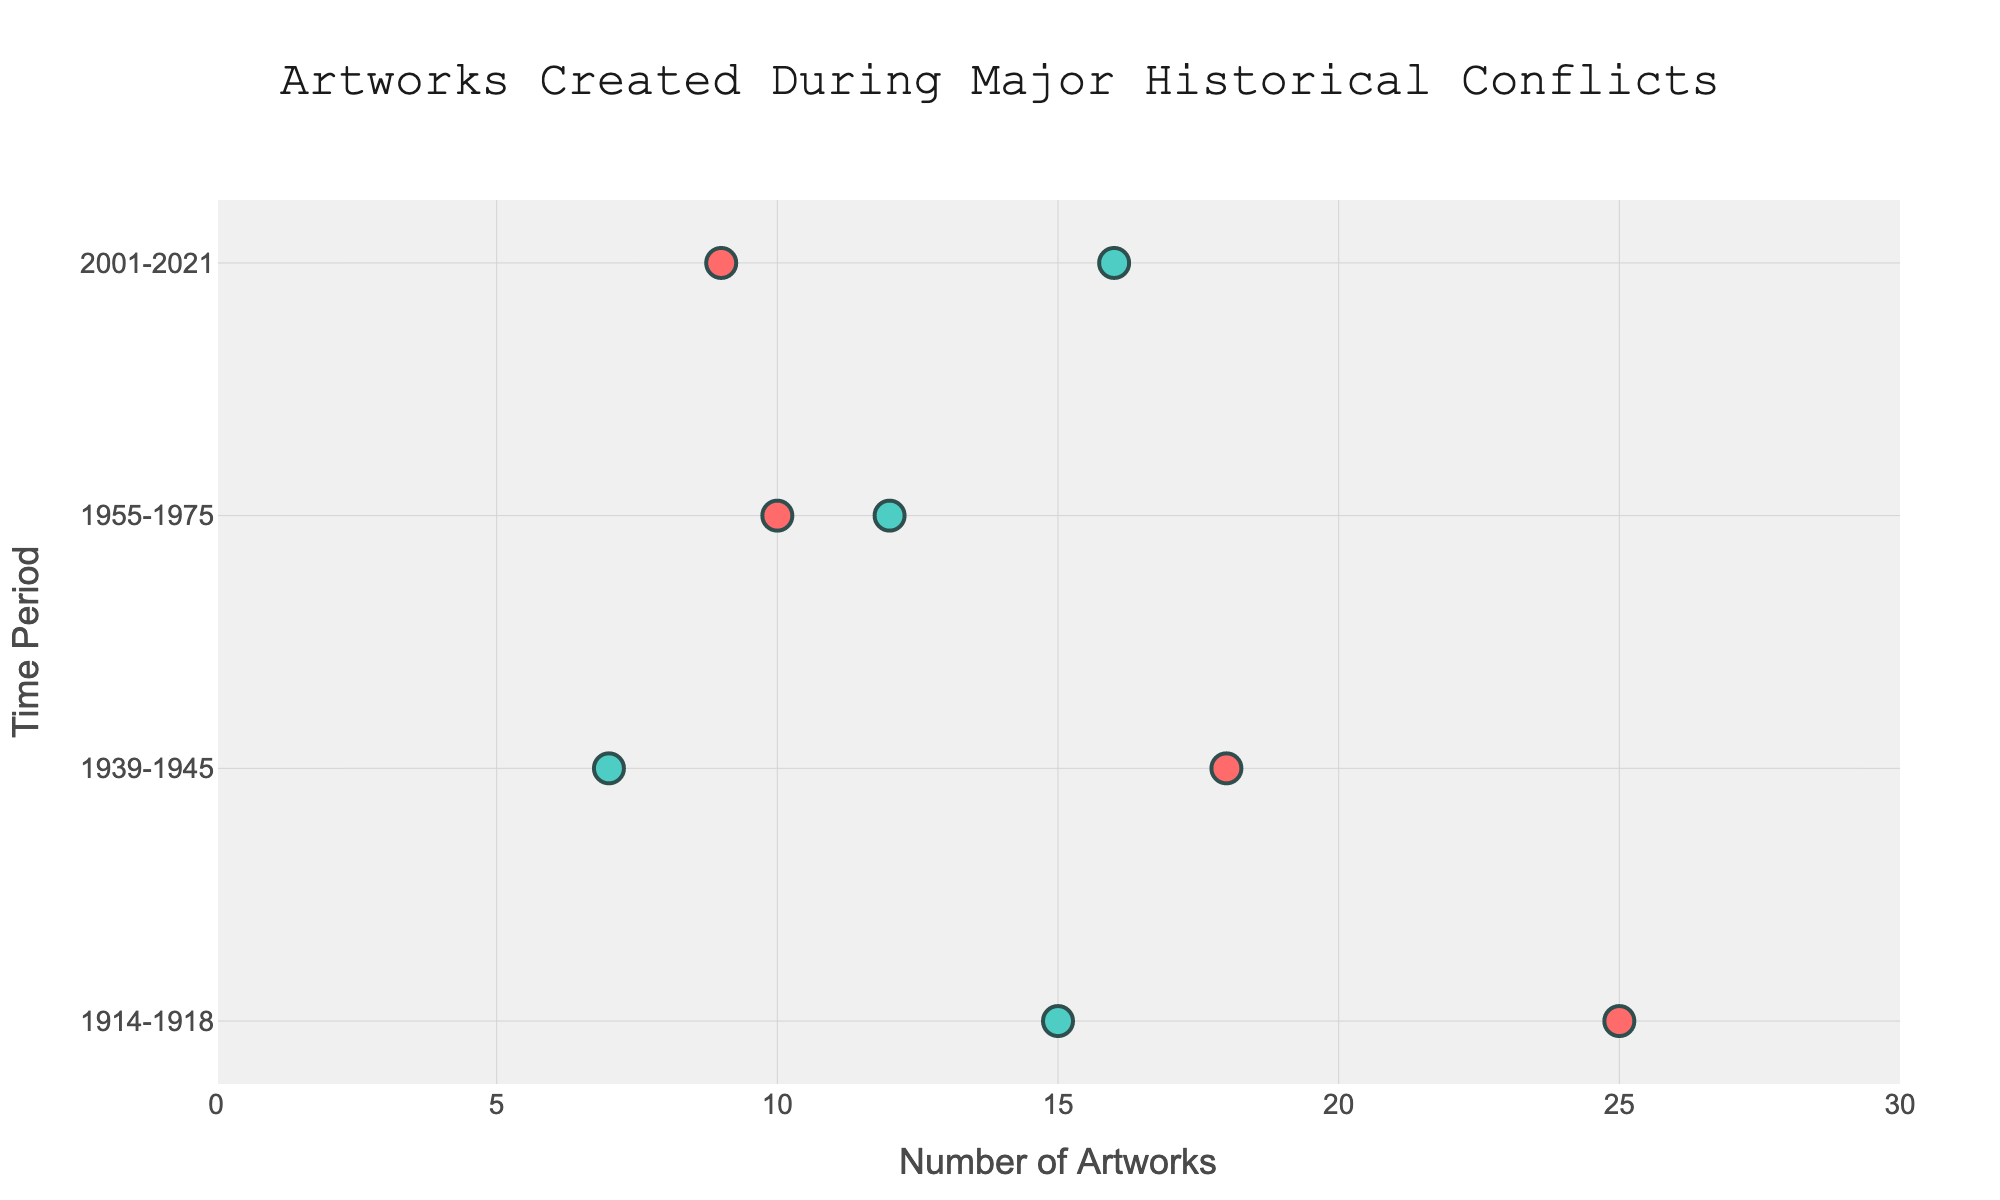what is the title of the figure? The title of the figure is displayed at the top center of the chart. It reads "Artworks Created During Major Historical Conflicts".
Answer: Artworks Created During Major Historical Conflicts how many artworks did Jackson Pollock create during World War II? Jackson Pollock created artworks during the 1939-1945 period, and his marker shows the number of artworks created, which is 7.
Answer: 7 which artist created the most peace-themed artworks during World War II? There are two artists associated with World War II in the chart: Salvador Dalí (bellicose) and Jackson Pollock (peace-themed). Pollock's peace-themed artworks total 7, making him the artist with the most peace-themed works for that period.
Answer: Jackson Pollock compare the number of peace-themed artworks created during the Vietnam War to the War on Terror For the Vietnam War, Yoko Ono (peace-themed) created 12 artworks, and for the War on Terror, Banksy (peace-themed) created 16 artworks. By comparing the values, we see that Banksy created more peace-themed artworks.
Answer: Banksy created more which time period had the highest total number of bellicose artworks? Adding up the number of bellicose artworks from each time period:
- World War I: 25 artworks by Otto Dix,
- World War II: 18 artworks by Salvador Dalí,
- Vietnam War: 10 artworks by Peter Saul,
- War on Terror: 9 artworks by Pablo Picasso.
The highest total is 25 during World War I.
Answer: World War I what is the difference in the number of peace-themed artworks between World War I and the Vietnam War? World War I had 15 peace-themed artworks by Käthe Kollwitz, and the Vietnam War had 12 peace-themed artworks by Yoko Ono. The difference is 15 - 12 = 3.
Answer: 3 how do the number of artworks by Käthe Kollwitz and Peter Saul compare in their respective time periods? Käthe Kollwitz created 15 peace-themed artworks during World War I, while Peter Saul created 10 bellicose artworks during the Vietnam War. By comparing the numbers, we see that Käthe Kollwitz created more artworks.
Answer: Käthe Kollwitz created more which time period had the most evenly split number of bellicose and peace-themed artworks? We can compare each time period:
- World War I: 25 bellicose and 15 peace-themed,
- World War II: 18 bellicose and 7 peace-themed,
- Vietnam War: 10 bellicose and 12 peace-themed,
- War on Terror: 9 bellicose and 16 peace-themed.
The Vietnam War had 10 bellicose and 12 peace-themed, making it the most evenly split.
Answer: Vietnam War what art movement is Peter Saul associated with based on the figure? The Ranged Dot Plot includes labels for each artist and their respective art movement. Peter Saul is associated with Pop Art during the Vietnam War.
Answer: Pop Art 